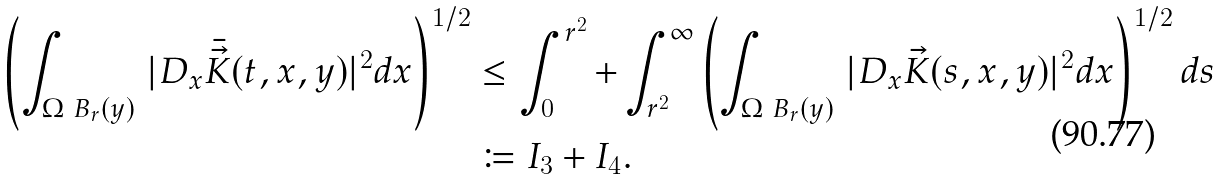<formula> <loc_0><loc_0><loc_500><loc_500>\left ( \int _ { \Omega \ B _ { r } ( y ) } \, | D _ { x } \bar { \vec { K } } ( t , x , y ) | ^ { 2 } d x \right ) ^ { 1 / 2 } & \leq \int _ { 0 } ^ { r ^ { 2 } } + \int _ { r ^ { 2 } } ^ { \infty } \left ( \int _ { \Omega \ B _ { r } ( y ) } \, | D _ { x } \vec { K } ( s , x , y ) | ^ { 2 } d x \right ) ^ { 1 / 2 } d s \\ & \coloneqq I _ { 3 } + I _ { 4 } .</formula> 